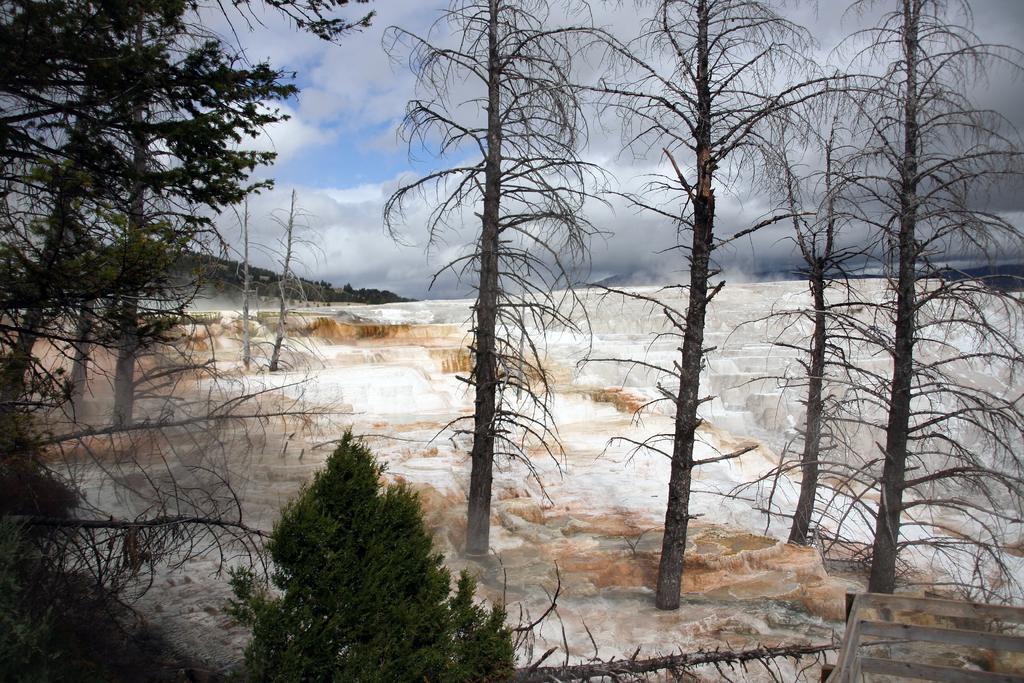Could you give a brief overview of what you see in this image? In this image the land is covered with snow and there are trees, in the background is a mountain and the sky. 